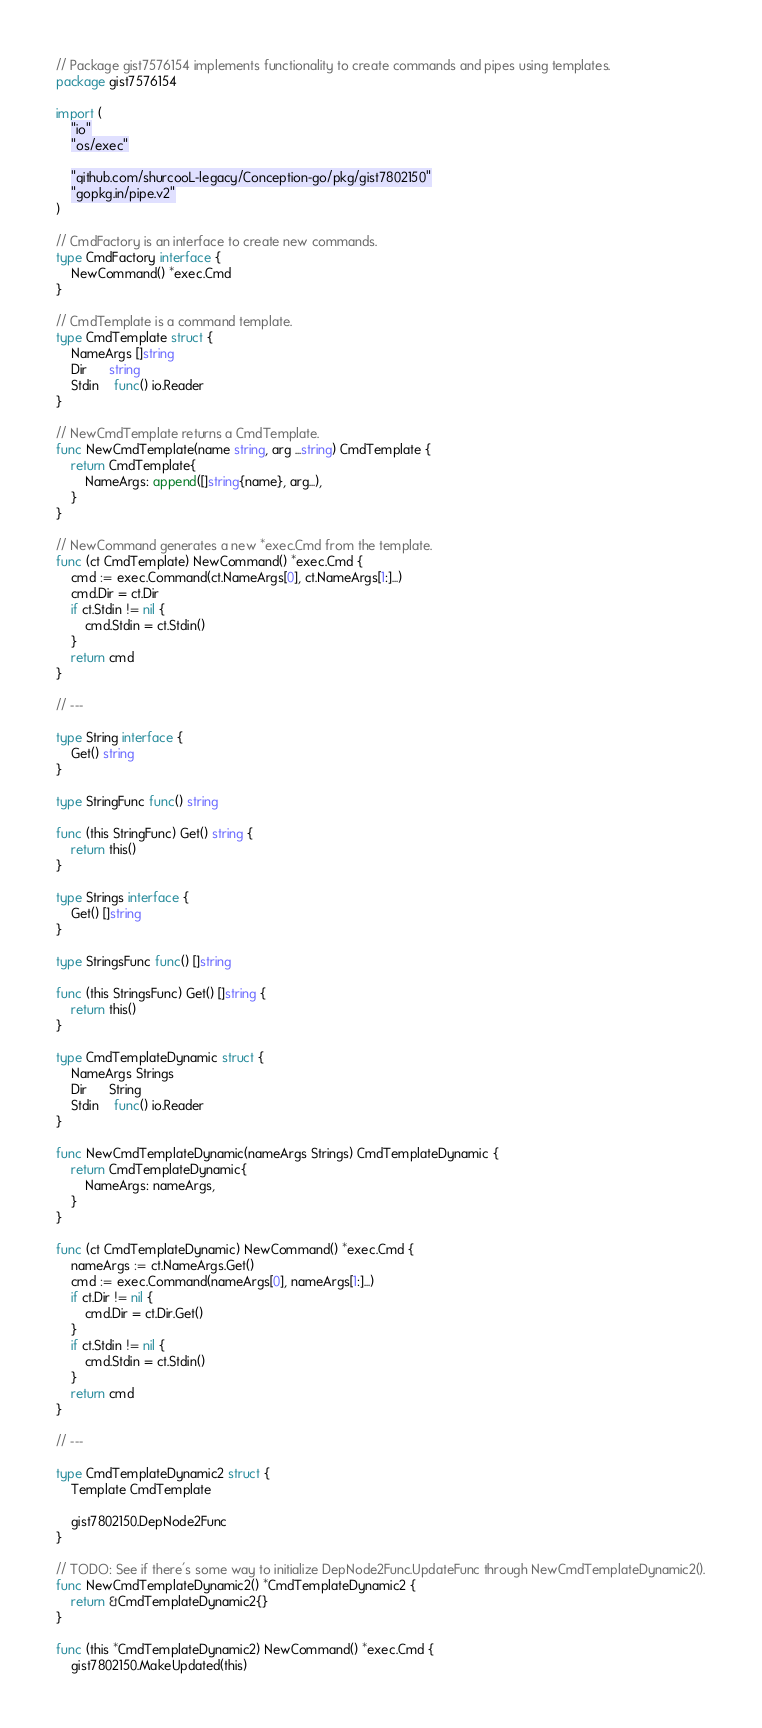Convert code to text. <code><loc_0><loc_0><loc_500><loc_500><_Go_>// Package gist7576154 implements functionality to create commands and pipes using templates.
package gist7576154

import (
	"io"
	"os/exec"

	"github.com/shurcooL-legacy/Conception-go/pkg/gist7802150"
	"gopkg.in/pipe.v2"
)

// CmdFactory is an interface to create new commands.
type CmdFactory interface {
	NewCommand() *exec.Cmd
}

// CmdTemplate is a command template.
type CmdTemplate struct {
	NameArgs []string
	Dir      string
	Stdin    func() io.Reader
}

// NewCmdTemplate returns a CmdTemplate.
func NewCmdTemplate(name string, arg ...string) CmdTemplate {
	return CmdTemplate{
		NameArgs: append([]string{name}, arg...),
	}
}

// NewCommand generates a new *exec.Cmd from the template.
func (ct CmdTemplate) NewCommand() *exec.Cmd {
	cmd := exec.Command(ct.NameArgs[0], ct.NameArgs[1:]...)
	cmd.Dir = ct.Dir
	if ct.Stdin != nil {
		cmd.Stdin = ct.Stdin()
	}
	return cmd
}

// ---

type String interface {
	Get() string
}

type StringFunc func() string

func (this StringFunc) Get() string {
	return this()
}

type Strings interface {
	Get() []string
}

type StringsFunc func() []string

func (this StringsFunc) Get() []string {
	return this()
}

type CmdTemplateDynamic struct {
	NameArgs Strings
	Dir      String
	Stdin    func() io.Reader
}

func NewCmdTemplateDynamic(nameArgs Strings) CmdTemplateDynamic {
	return CmdTemplateDynamic{
		NameArgs: nameArgs,
	}
}

func (ct CmdTemplateDynamic) NewCommand() *exec.Cmd {
	nameArgs := ct.NameArgs.Get()
	cmd := exec.Command(nameArgs[0], nameArgs[1:]...)
	if ct.Dir != nil {
		cmd.Dir = ct.Dir.Get()
	}
	if ct.Stdin != nil {
		cmd.Stdin = ct.Stdin()
	}
	return cmd
}

// ---

type CmdTemplateDynamic2 struct {
	Template CmdTemplate

	gist7802150.DepNode2Func
}

// TODO: See if there's some way to initialize DepNode2Func.UpdateFunc through NewCmdTemplateDynamic2().
func NewCmdTemplateDynamic2() *CmdTemplateDynamic2 {
	return &CmdTemplateDynamic2{}
}

func (this *CmdTemplateDynamic2) NewCommand() *exec.Cmd {
	gist7802150.MakeUpdated(this)</code> 